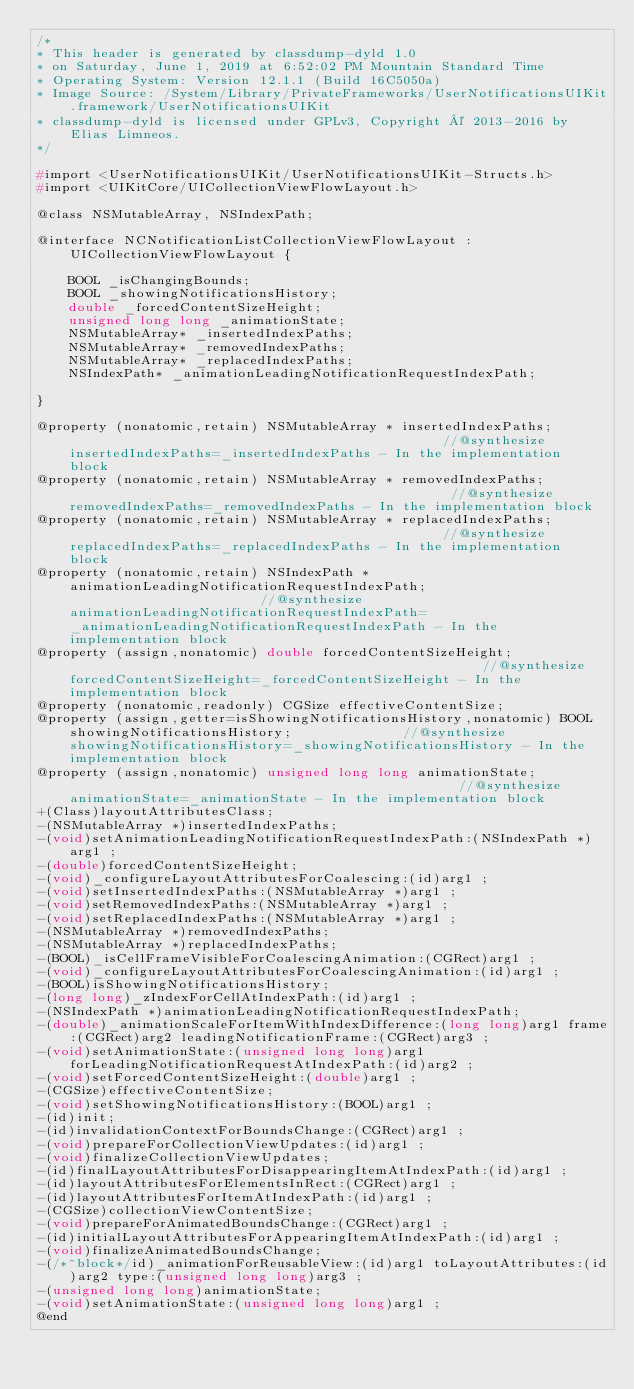Convert code to text. <code><loc_0><loc_0><loc_500><loc_500><_C_>/*
* This header is generated by classdump-dyld 1.0
* on Saturday, June 1, 2019 at 6:52:02 PM Mountain Standard Time
* Operating System: Version 12.1.1 (Build 16C5050a)
* Image Source: /System/Library/PrivateFrameworks/UserNotificationsUIKit.framework/UserNotificationsUIKit
* classdump-dyld is licensed under GPLv3, Copyright © 2013-2016 by Elias Limneos.
*/

#import <UserNotificationsUIKit/UserNotificationsUIKit-Structs.h>
#import <UIKitCore/UICollectionViewFlowLayout.h>

@class NSMutableArray, NSIndexPath;

@interface NCNotificationListCollectionViewFlowLayout : UICollectionViewFlowLayout {

	BOOL _isChangingBounds;
	BOOL _showingNotificationsHistory;
	double _forcedContentSizeHeight;
	unsigned long long _animationState;
	NSMutableArray* _insertedIndexPaths;
	NSMutableArray* _removedIndexPaths;
	NSMutableArray* _replacedIndexPaths;
	NSIndexPath* _animationLeadingNotificationRequestIndexPath;

}

@property (nonatomic,retain) NSMutableArray * insertedIndexPaths;                                                //@synthesize insertedIndexPaths=_insertedIndexPaths - In the implementation block
@property (nonatomic,retain) NSMutableArray * removedIndexPaths;                                                 //@synthesize removedIndexPaths=_removedIndexPaths - In the implementation block
@property (nonatomic,retain) NSMutableArray * replacedIndexPaths;                                                //@synthesize replacedIndexPaths=_replacedIndexPaths - In the implementation block
@property (nonatomic,retain) NSIndexPath * animationLeadingNotificationRequestIndexPath;                         //@synthesize animationLeadingNotificationRequestIndexPath=_animationLeadingNotificationRequestIndexPath - In the implementation block
@property (assign,nonatomic) double forcedContentSizeHeight;                                                     //@synthesize forcedContentSizeHeight=_forcedContentSizeHeight - In the implementation block
@property (nonatomic,readonly) CGSize effectiveContentSize; 
@property (assign,getter=isShowingNotificationsHistory,nonatomic) BOOL showingNotificationsHistory;              //@synthesize showingNotificationsHistory=_showingNotificationsHistory - In the implementation block
@property (assign,nonatomic) unsigned long long animationState;                                                  //@synthesize animationState=_animationState - In the implementation block
+(Class)layoutAttributesClass;
-(NSMutableArray *)insertedIndexPaths;
-(void)setAnimationLeadingNotificationRequestIndexPath:(NSIndexPath *)arg1 ;
-(double)forcedContentSizeHeight;
-(void)_configureLayoutAttributesForCoalescing:(id)arg1 ;
-(void)setInsertedIndexPaths:(NSMutableArray *)arg1 ;
-(void)setRemovedIndexPaths:(NSMutableArray *)arg1 ;
-(void)setReplacedIndexPaths:(NSMutableArray *)arg1 ;
-(NSMutableArray *)removedIndexPaths;
-(NSMutableArray *)replacedIndexPaths;
-(BOOL)_isCellFrameVisibleForCoalescingAnimation:(CGRect)arg1 ;
-(void)_configureLayoutAttributesForCoalescingAnimation:(id)arg1 ;
-(BOOL)isShowingNotificationsHistory;
-(long long)_zIndexForCellAtIndexPath:(id)arg1 ;
-(NSIndexPath *)animationLeadingNotificationRequestIndexPath;
-(double)_animationScaleForItemWithIndexDifference:(long long)arg1 frame:(CGRect)arg2 leadingNotificationFrame:(CGRect)arg3 ;
-(void)setAnimationState:(unsigned long long)arg1 forLeadingNotificationRequestAtIndexPath:(id)arg2 ;
-(void)setForcedContentSizeHeight:(double)arg1 ;
-(CGSize)effectiveContentSize;
-(void)setShowingNotificationsHistory:(BOOL)arg1 ;
-(id)init;
-(id)invalidationContextForBoundsChange:(CGRect)arg1 ;
-(void)prepareForCollectionViewUpdates:(id)arg1 ;
-(void)finalizeCollectionViewUpdates;
-(id)finalLayoutAttributesForDisappearingItemAtIndexPath:(id)arg1 ;
-(id)layoutAttributesForElementsInRect:(CGRect)arg1 ;
-(id)layoutAttributesForItemAtIndexPath:(id)arg1 ;
-(CGSize)collectionViewContentSize;
-(void)prepareForAnimatedBoundsChange:(CGRect)arg1 ;
-(id)initialLayoutAttributesForAppearingItemAtIndexPath:(id)arg1 ;
-(void)finalizeAnimatedBoundsChange;
-(/*^block*/id)_animationForReusableView:(id)arg1 toLayoutAttributes:(id)arg2 type:(unsigned long long)arg3 ;
-(unsigned long long)animationState;
-(void)setAnimationState:(unsigned long long)arg1 ;
@end

</code> 